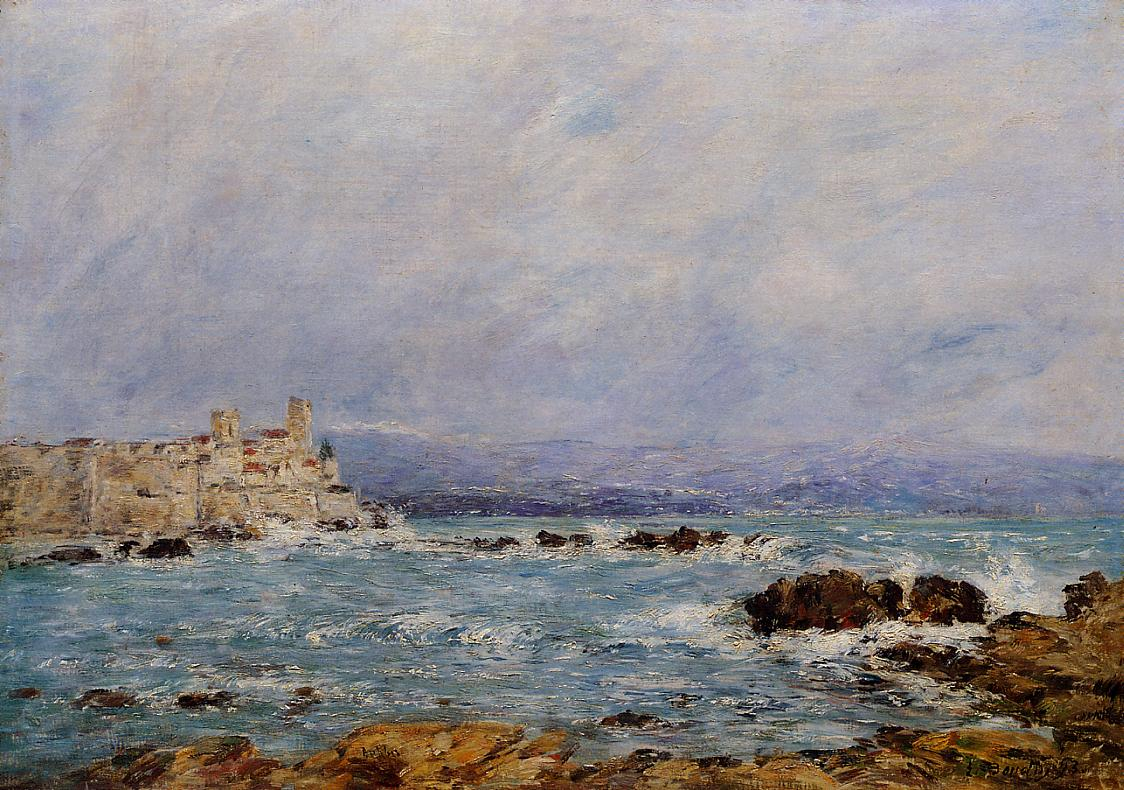What are the key elements in this picture? The image showcases an evocative impressionist landscape painting, expertly executed in oil on canvas. Dominating the scene is a rocky coastline, rich in dark green hues suggestive of moss. The sea, with its dynamic dark blue tones mixed with whitecaps, adds a sense of movement. In the background, a light beige castle stands proudly on a cliff, contrasting beautifully with the blue sea and sky. The sky itself is light blue with delicate, wispy clouds, lending tranquility to the composition. The painting is signed in the lower right corner, indicating the artist's identity as Claude Monet. This beautifully captures Monet's characteristic style, showcasing his talent in portraying light and color to evoke sensory experiences. 